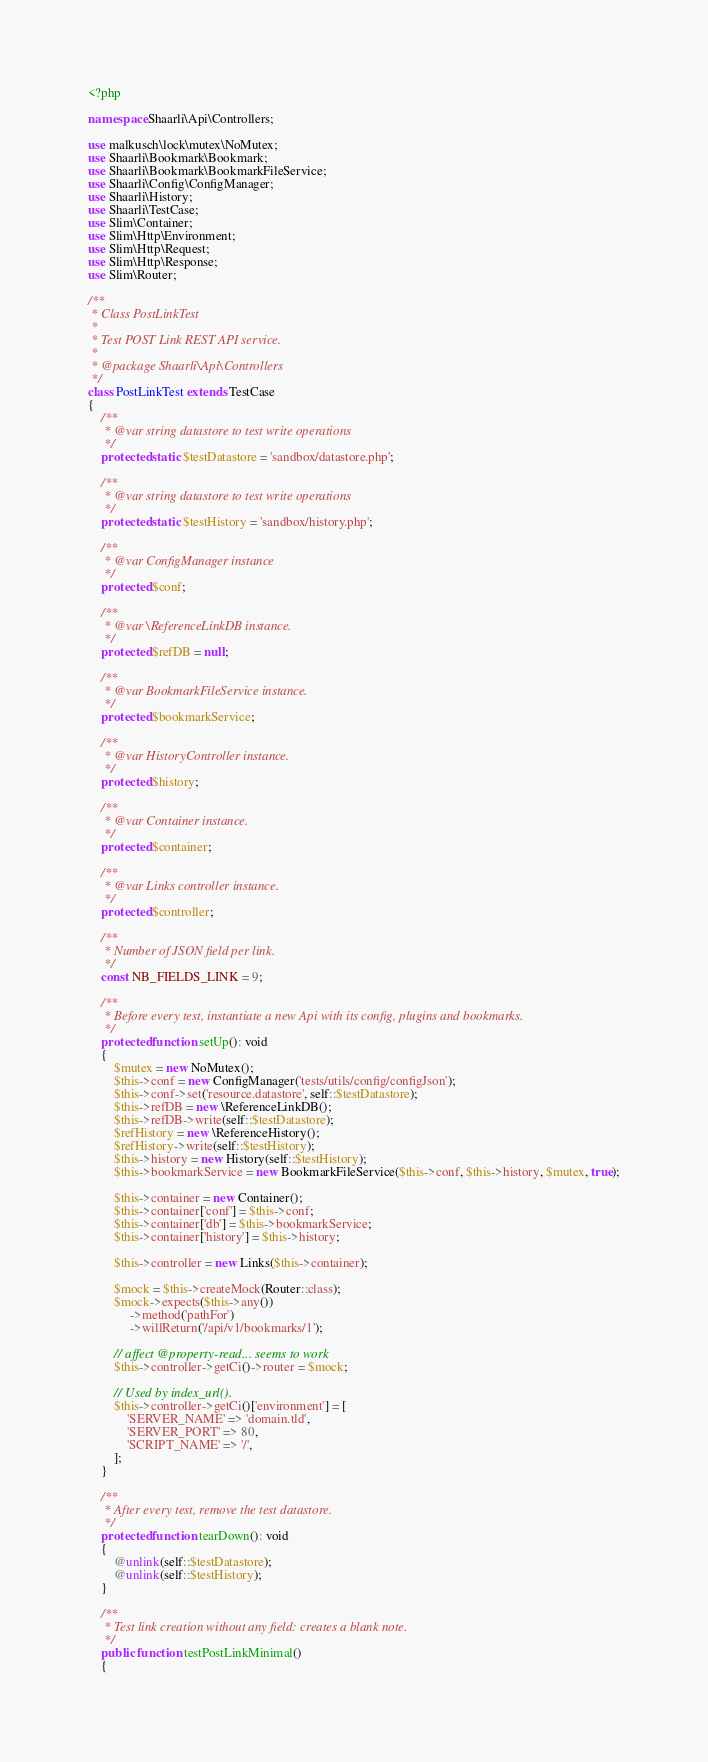Convert code to text. <code><loc_0><loc_0><loc_500><loc_500><_PHP_><?php

namespace Shaarli\Api\Controllers;

use malkusch\lock\mutex\NoMutex;
use Shaarli\Bookmark\Bookmark;
use Shaarli\Bookmark\BookmarkFileService;
use Shaarli\Config\ConfigManager;
use Shaarli\History;
use Shaarli\TestCase;
use Slim\Container;
use Slim\Http\Environment;
use Slim\Http\Request;
use Slim\Http\Response;
use Slim\Router;

/**
 * Class PostLinkTest
 *
 * Test POST Link REST API service.
 *
 * @package Shaarli\Api\Controllers
 */
class PostLinkTest extends TestCase
{
    /**
     * @var string datastore to test write operations
     */
    protected static $testDatastore = 'sandbox/datastore.php';

    /**
     * @var string datastore to test write operations
     */
    protected static $testHistory = 'sandbox/history.php';

    /**
     * @var ConfigManager instance
     */
    protected $conf;

    /**
     * @var \ReferenceLinkDB instance.
     */
    protected $refDB = null;

    /**
     * @var BookmarkFileService instance.
     */
    protected $bookmarkService;

    /**
     * @var HistoryController instance.
     */
    protected $history;

    /**
     * @var Container instance.
     */
    protected $container;

    /**
     * @var Links controller instance.
     */
    protected $controller;

    /**
     * Number of JSON field per link.
     */
    const NB_FIELDS_LINK = 9;

    /**
     * Before every test, instantiate a new Api with its config, plugins and bookmarks.
     */
    protected function setUp(): void
    {
        $mutex = new NoMutex();
        $this->conf = new ConfigManager('tests/utils/config/configJson');
        $this->conf->set('resource.datastore', self::$testDatastore);
        $this->refDB = new \ReferenceLinkDB();
        $this->refDB->write(self::$testDatastore);
        $refHistory = new \ReferenceHistory();
        $refHistory->write(self::$testHistory);
        $this->history = new History(self::$testHistory);
        $this->bookmarkService = new BookmarkFileService($this->conf, $this->history, $mutex, true);

        $this->container = new Container();
        $this->container['conf'] = $this->conf;
        $this->container['db'] = $this->bookmarkService;
        $this->container['history'] = $this->history;

        $this->controller = new Links($this->container);

        $mock = $this->createMock(Router::class);
        $mock->expects($this->any())
             ->method('pathFor')
             ->willReturn('/api/v1/bookmarks/1');

        // affect @property-read... seems to work
        $this->controller->getCi()->router = $mock;

        // Used by index_url().
        $this->controller->getCi()['environment'] = [
            'SERVER_NAME' => 'domain.tld',
            'SERVER_PORT' => 80,
            'SCRIPT_NAME' => '/',
        ];
    }

    /**
     * After every test, remove the test datastore.
     */
    protected function tearDown(): void
    {
        @unlink(self::$testDatastore);
        @unlink(self::$testHistory);
    }

    /**
     * Test link creation without any field: creates a blank note.
     */
    public function testPostLinkMinimal()
    {</code> 